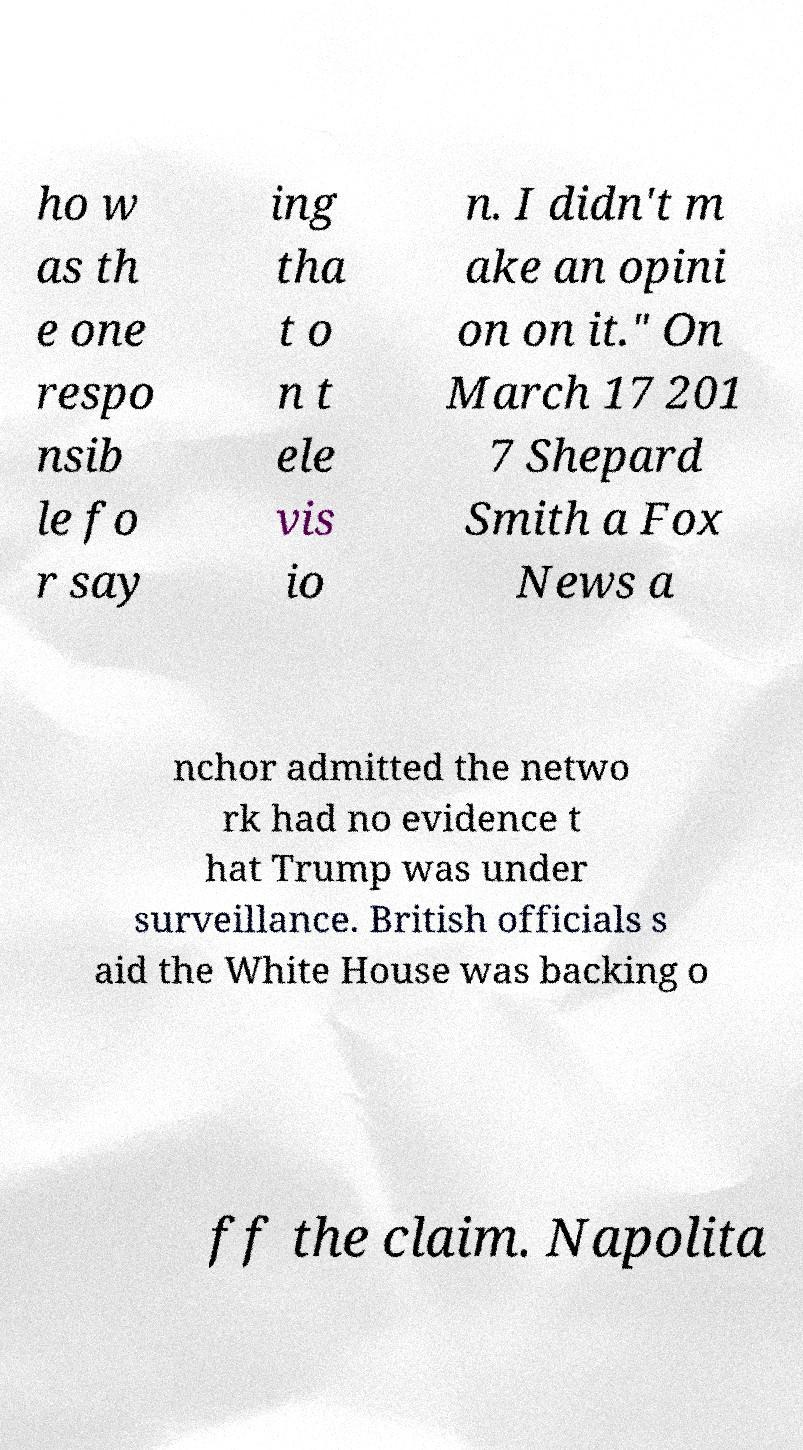Can you read and provide the text displayed in the image?This photo seems to have some interesting text. Can you extract and type it out for me? ho w as th e one respo nsib le fo r say ing tha t o n t ele vis io n. I didn't m ake an opini on on it." On March 17 201 7 Shepard Smith a Fox News a nchor admitted the netwo rk had no evidence t hat Trump was under surveillance. British officials s aid the White House was backing o ff the claim. Napolita 